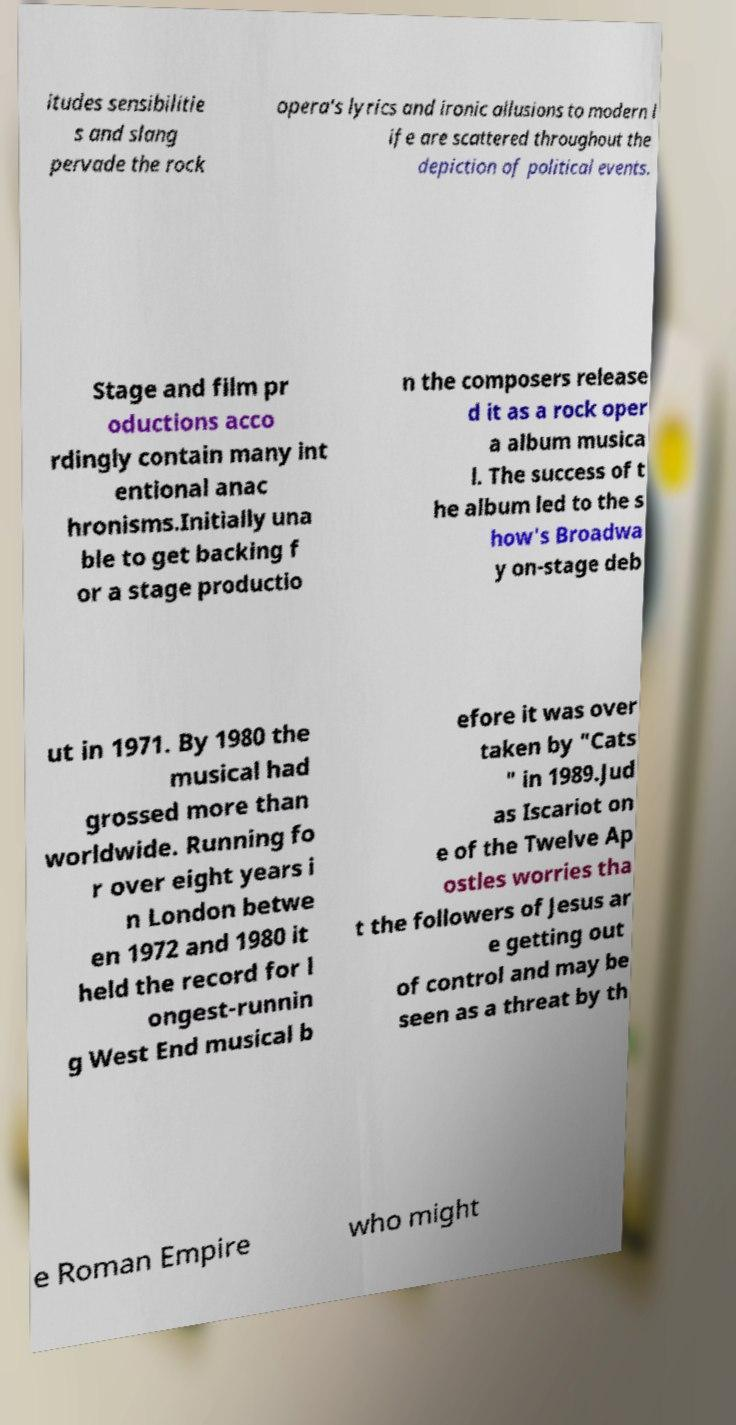For documentation purposes, I need the text within this image transcribed. Could you provide that? itudes sensibilitie s and slang pervade the rock opera's lyrics and ironic allusions to modern l ife are scattered throughout the depiction of political events. Stage and film pr oductions acco rdingly contain many int entional anac hronisms.Initially una ble to get backing f or a stage productio n the composers release d it as a rock oper a album musica l. The success of t he album led to the s how's Broadwa y on-stage deb ut in 1971. By 1980 the musical had grossed more than worldwide. Running fo r over eight years i n London betwe en 1972 and 1980 it held the record for l ongest-runnin g West End musical b efore it was over taken by "Cats " in 1989.Jud as Iscariot on e of the Twelve Ap ostles worries tha t the followers of Jesus ar e getting out of control and may be seen as a threat by th e Roman Empire who might 